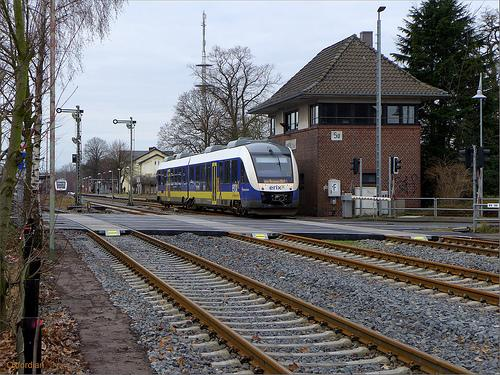List three objects found in the image, excluding the train. Brick train station building, tall gray lamp post, and metal street light. Which direction are the white clouds located in relation to the train? The white clouds are located above the train in the blue sky. Describe the state of the train in the image. The train is stationary and not moving, parked at the train station on train tracks. Mention two distinctive features of the train. Yellow stripe on the passenger train and glass windshield on the front. What is the color of the graffiti on the side of the building? The graffiti is black. How many train tracks are there and what is underneath them? There are three train tracks with grey gravel underneath. What lies on the other side of the train tracks, besides the gravel? There are loose grey stones and metal fencing on the other side of the train tracks. What is the general atmosphere and setting of the image? A train station with multiple train tracks, gravel, and a surrounding brick building under a blue sky with white clouds. Identify the primary mode of transportation in the image. A blue, white, and yellow passenger train at a station. Explain the purpose of the platform featured in the image. The platform serves as an area for pedestrians to cross or wait for the train. 